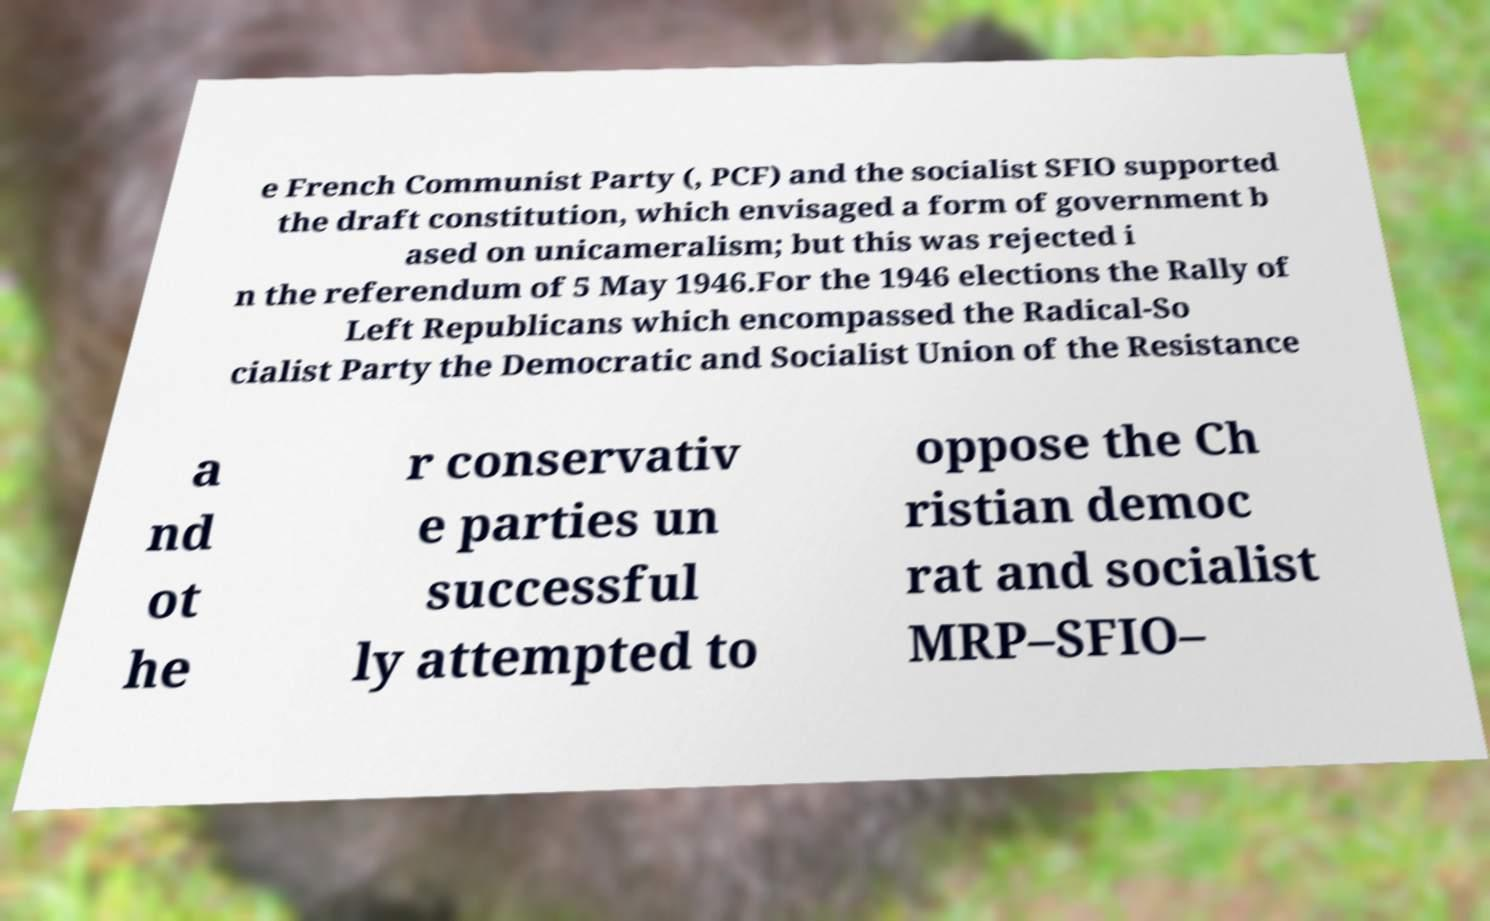Please identify and transcribe the text found in this image. e French Communist Party (, PCF) and the socialist SFIO supported the draft constitution, which envisaged a form of government b ased on unicameralism; but this was rejected i n the referendum of 5 May 1946.For the 1946 elections the Rally of Left Republicans which encompassed the Radical-So cialist Party the Democratic and Socialist Union of the Resistance a nd ot he r conservativ e parties un successful ly attempted to oppose the Ch ristian democ rat and socialist MRP–SFIO– 